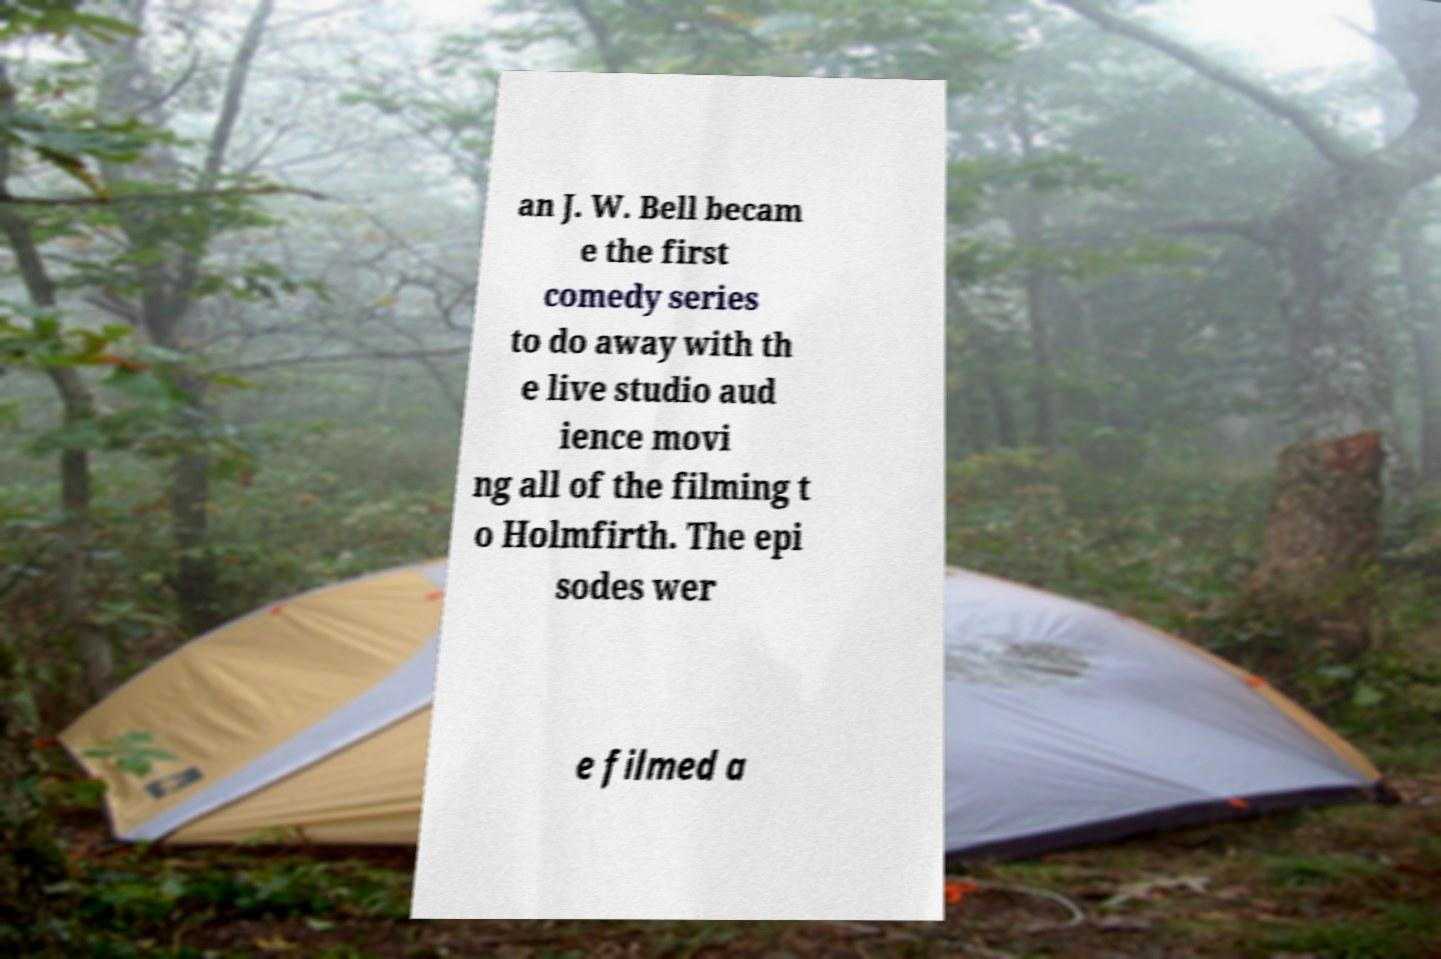Could you extract and type out the text from this image? an J. W. Bell becam e the first comedy series to do away with th e live studio aud ience movi ng all of the filming t o Holmfirth. The epi sodes wer e filmed a 